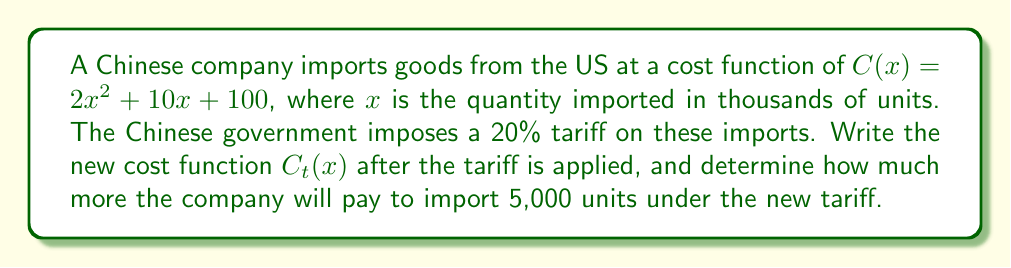Help me with this question. 1) The original cost function is $C(x) = 2x^2 + 10x + 100$.

2) A 20% tariff means the cost will increase by 20%. We can represent this as multiplying the original function by 1.20:

   $C_t(x) = 1.20 \cdot C(x)$

3) Substitute the original function:
   
   $C_t(x) = 1.20 \cdot (2x^2 + 10x + 100)$

4) Distribute the 1.20:
   
   $C_t(x) = 2.40x^2 + 12x + 120$

5) To find the cost difference for 5,000 units, we need to calculate for $x = 5$ (remember, $x$ is in thousands of units).

6) Cost before tariff:
   $C(5) = 2(5)^2 + 10(5) + 100 = 50 + 50 + 100 = 200$

7) Cost after tariff:
   $C_t(5) = 2.40(5)^2 + 12(5) + 120 = 60 + 60 + 120 = 240$

8) Difference in cost:
   $240 - 200 = 40$

Therefore, the company will pay 40 thousand currency units more for 5,000 units under the new tariff.
Answer: $C_t(x) = 2.40x^2 + 12x + 120$; 40 thousand currency units 